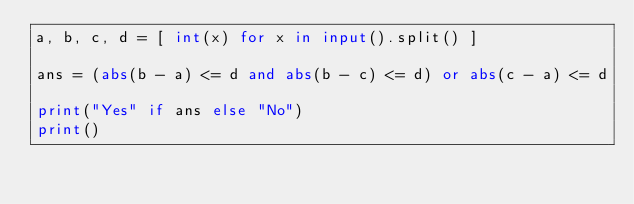<code> <loc_0><loc_0><loc_500><loc_500><_Python_>a, b, c, d = [ int(x) for x in input().split() ]

ans = (abs(b - a) <= d and abs(b - c) <= d) or abs(c - a) <= d

print("Yes" if ans else "No")
print()
</code> 